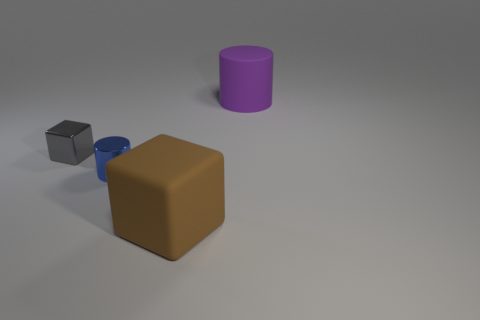There is a cylinder to the left of the brown cube; how many things are behind it?
Offer a very short reply. 2. How many brown objects are the same material as the blue thing?
Your answer should be compact. 0. There is a big rubber cube; are there any big purple rubber things right of it?
Make the answer very short. Yes. What is the color of the block that is the same size as the blue object?
Give a very brief answer. Gray. What number of objects are either big matte objects behind the gray metallic object or large brown rubber cylinders?
Make the answer very short. 1. What size is the object that is both left of the purple cylinder and right of the metallic cylinder?
Offer a very short reply. Large. The large thing that is behind the large matte object to the left of the large matte object that is on the right side of the big brown cube is what color?
Keep it short and to the point. Purple. What is the shape of the object that is behind the small blue object and to the left of the brown rubber cube?
Your answer should be very brief. Cube. What shape is the thing to the right of the big thing that is in front of the cylinder that is in front of the large purple object?
Offer a very short reply. Cylinder. How many objects are either gray metallic blocks or large rubber objects in front of the small gray shiny block?
Your answer should be compact. 2. 